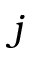Convert formula to latex. <formula><loc_0><loc_0><loc_500><loc_500>j</formula> 